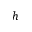<formula> <loc_0><loc_0><loc_500><loc_500>h</formula> 